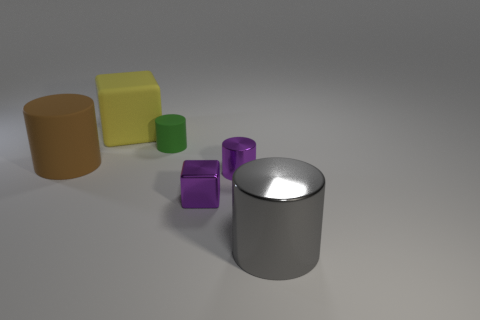Subtract all purple metallic cylinders. How many cylinders are left? 3 Subtract 1 cylinders. How many cylinders are left? 3 Subtract all cyan cylinders. Subtract all brown blocks. How many cylinders are left? 4 Subtract all cylinders. How many objects are left? 2 Add 2 large red things. How many objects exist? 8 Add 5 green cylinders. How many green cylinders exist? 6 Subtract 0 yellow spheres. How many objects are left? 6 Subtract all big blue rubber things. Subtract all purple metallic cylinders. How many objects are left? 5 Add 1 metal things. How many metal things are left? 4 